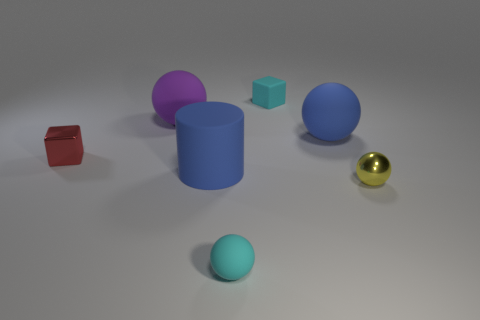What color is the matte ball that is the same size as the purple thing? The ball that matches the size of the purple cylinder is blue. It exhibits a matte finish, which contrasts with the shinier textures of the nearby objects, such as the reflective golden ball. 